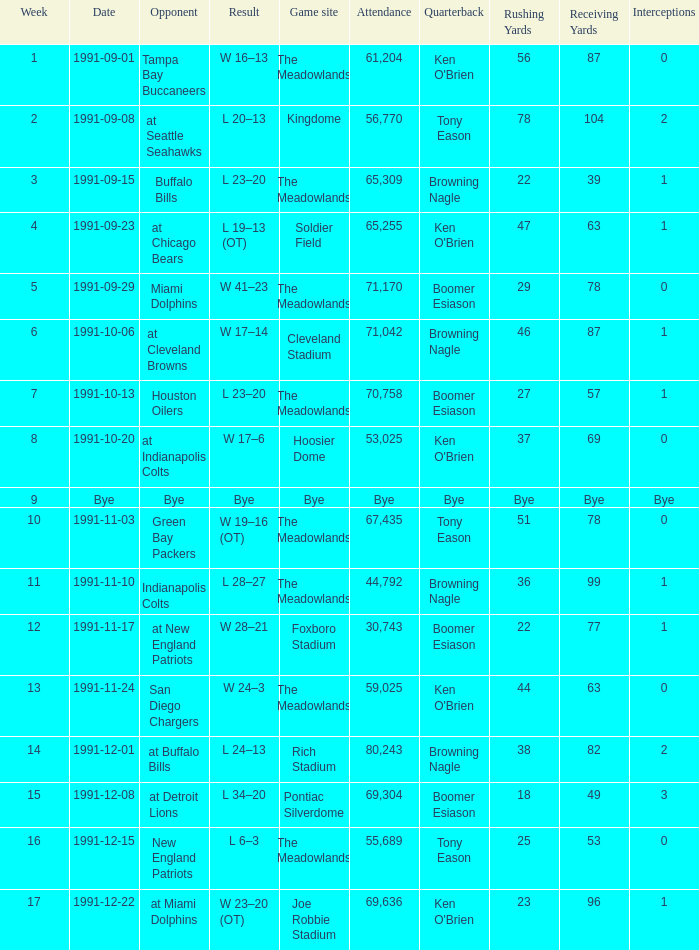What was the Attendance of the Game at Hoosier Dome? 53025.0. 